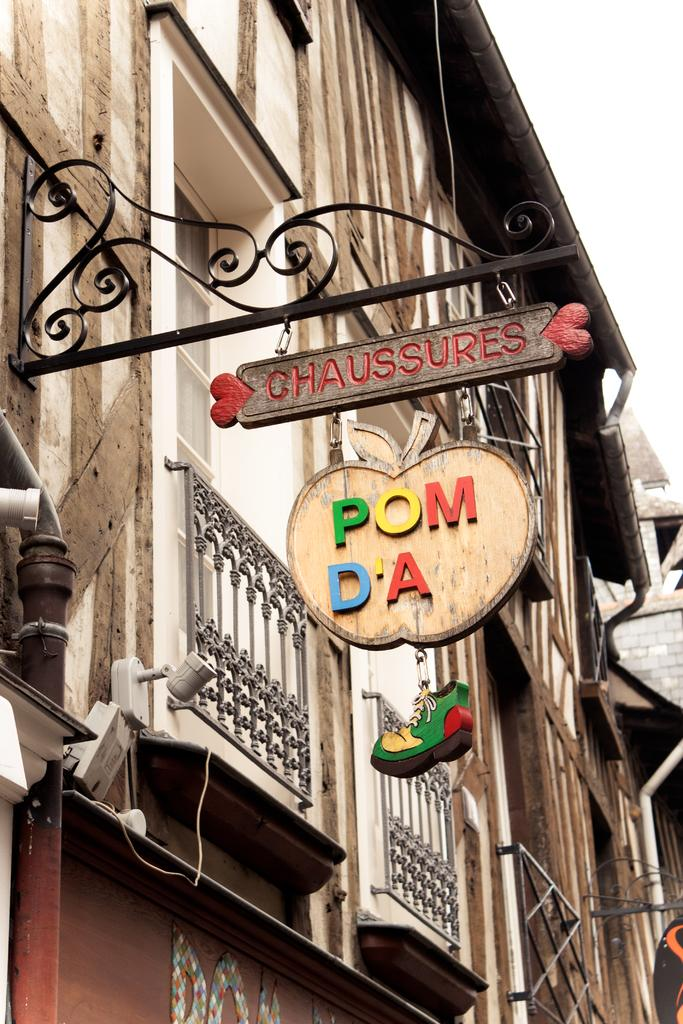<image>
Render a clear and concise summary of the photo. Store front with a sign which says "Chaussures" on it. 